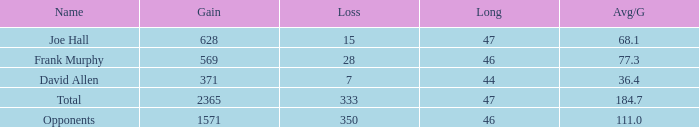How much Loss has a Gain smaller than 1571, and a Long smaller than 47, and an Avg/G of 36.4? 1.0. 